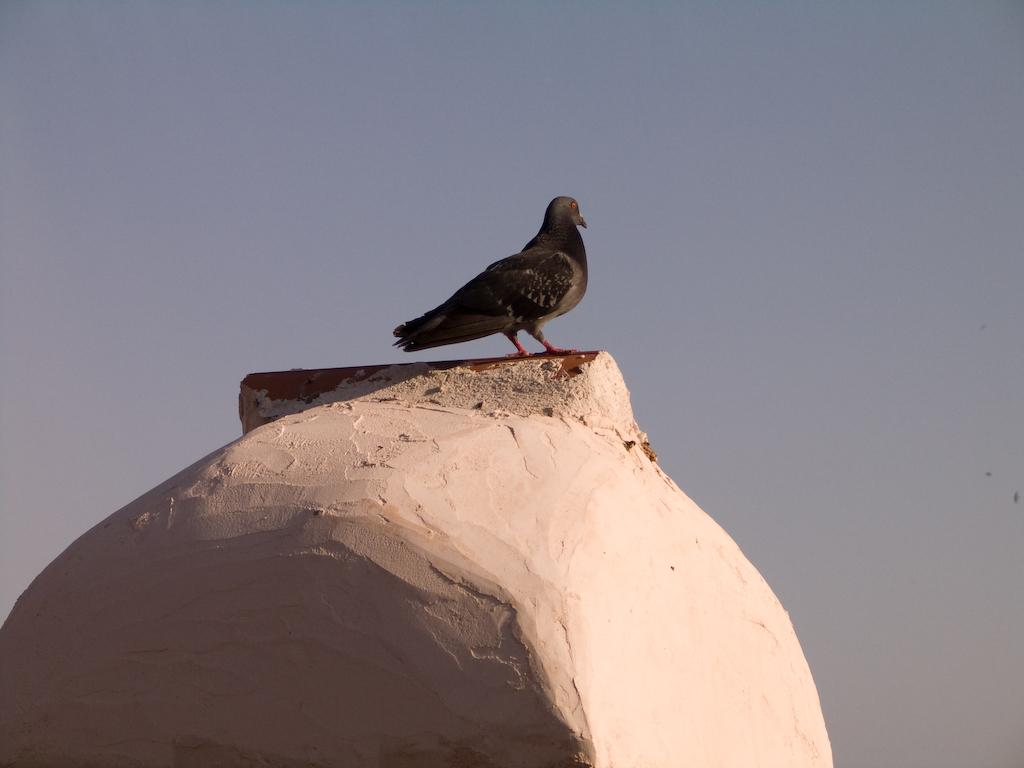What is the main subject of the image? There is a bird on a concrete surface in the image. What can be seen in the background of the image? The sky is visible in the background of the image. How would you describe the sky in the image? The sky appears cloudy in the image. Where is the crate located in the image? There is no crate present in the image. What color is the curtain in the image? There is no curtain present in the image. 